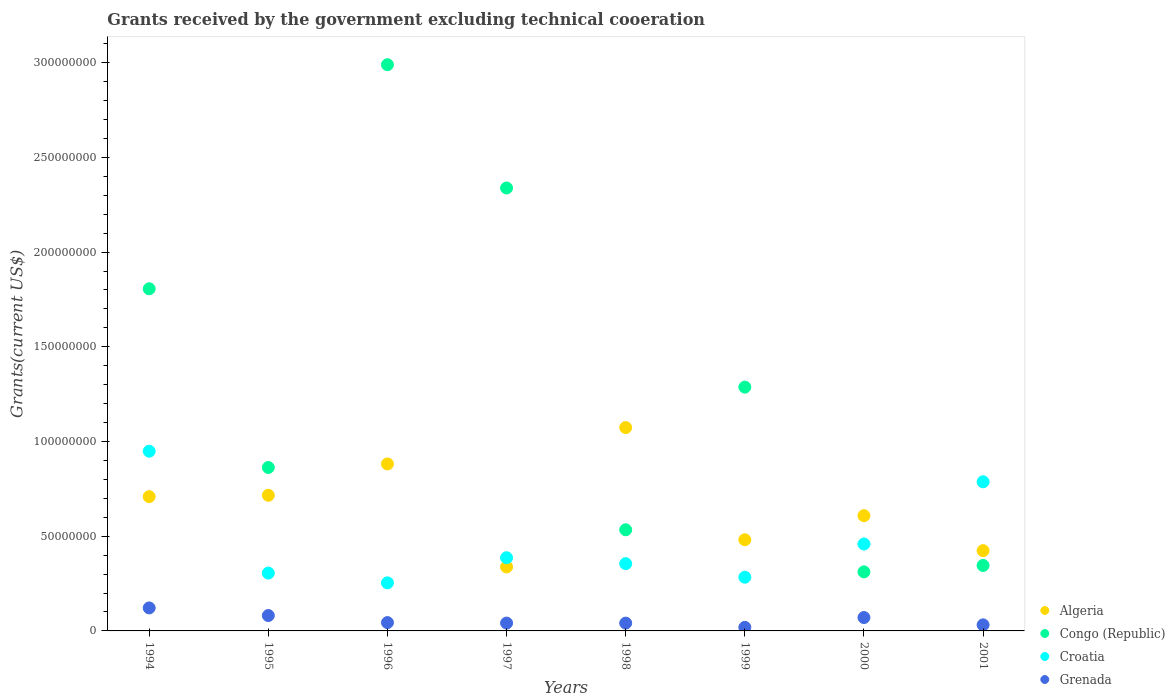Is the number of dotlines equal to the number of legend labels?
Offer a terse response. Yes. What is the total grants received by the government in Croatia in 1999?
Offer a very short reply. 2.84e+07. Across all years, what is the maximum total grants received by the government in Croatia?
Offer a terse response. 9.49e+07. Across all years, what is the minimum total grants received by the government in Grenada?
Provide a succinct answer. 1.88e+06. In which year was the total grants received by the government in Grenada maximum?
Ensure brevity in your answer.  1994. What is the total total grants received by the government in Algeria in the graph?
Provide a succinct answer. 5.23e+08. What is the difference between the total grants received by the government in Algeria in 1995 and that in 1998?
Your answer should be compact. -3.58e+07. What is the difference between the total grants received by the government in Algeria in 1995 and the total grants received by the government in Grenada in 2000?
Keep it short and to the point. 6.45e+07. What is the average total grants received by the government in Grenada per year?
Offer a very short reply. 5.63e+06. In the year 2001, what is the difference between the total grants received by the government in Algeria and total grants received by the government in Grenada?
Provide a succinct answer. 3.92e+07. What is the ratio of the total grants received by the government in Congo (Republic) in 1997 to that in 1999?
Your response must be concise. 1.82. Is the total grants received by the government in Congo (Republic) in 1995 less than that in 1999?
Ensure brevity in your answer.  Yes. Is the difference between the total grants received by the government in Algeria in 1996 and 2000 greater than the difference between the total grants received by the government in Grenada in 1996 and 2000?
Your answer should be very brief. Yes. What is the difference between the highest and the second highest total grants received by the government in Algeria?
Keep it short and to the point. 1.92e+07. What is the difference between the highest and the lowest total grants received by the government in Croatia?
Your answer should be compact. 6.95e+07. Is it the case that in every year, the sum of the total grants received by the government in Croatia and total grants received by the government in Congo (Republic)  is greater than the total grants received by the government in Algeria?
Your response must be concise. No. Is the total grants received by the government in Grenada strictly greater than the total grants received by the government in Croatia over the years?
Your answer should be compact. No. Is the total grants received by the government in Croatia strictly less than the total grants received by the government in Algeria over the years?
Give a very brief answer. No. How many dotlines are there?
Make the answer very short. 4. What is the title of the graph?
Provide a short and direct response. Grants received by the government excluding technical cooeration. Does "Jordan" appear as one of the legend labels in the graph?
Offer a terse response. No. What is the label or title of the Y-axis?
Give a very brief answer. Grants(current US$). What is the Grants(current US$) in Algeria in 1994?
Your response must be concise. 7.09e+07. What is the Grants(current US$) of Congo (Republic) in 1994?
Your answer should be compact. 1.81e+08. What is the Grants(current US$) of Croatia in 1994?
Provide a short and direct response. 9.49e+07. What is the Grants(current US$) in Grenada in 1994?
Keep it short and to the point. 1.21e+07. What is the Grants(current US$) in Algeria in 1995?
Offer a terse response. 7.16e+07. What is the Grants(current US$) in Congo (Republic) in 1995?
Keep it short and to the point. 8.63e+07. What is the Grants(current US$) of Croatia in 1995?
Your answer should be very brief. 3.05e+07. What is the Grants(current US$) of Grenada in 1995?
Provide a short and direct response. 8.12e+06. What is the Grants(current US$) in Algeria in 1996?
Your answer should be compact. 8.82e+07. What is the Grants(current US$) in Congo (Republic) in 1996?
Provide a short and direct response. 2.99e+08. What is the Grants(current US$) of Croatia in 1996?
Offer a very short reply. 2.54e+07. What is the Grants(current US$) of Grenada in 1996?
Provide a short and direct response. 4.40e+06. What is the Grants(current US$) of Algeria in 1997?
Make the answer very short. 3.38e+07. What is the Grants(current US$) in Congo (Republic) in 1997?
Keep it short and to the point. 2.34e+08. What is the Grants(current US$) of Croatia in 1997?
Provide a succinct answer. 3.86e+07. What is the Grants(current US$) of Grenada in 1997?
Give a very brief answer. 4.14e+06. What is the Grants(current US$) of Algeria in 1998?
Your response must be concise. 1.07e+08. What is the Grants(current US$) of Congo (Republic) in 1998?
Provide a short and direct response. 5.34e+07. What is the Grants(current US$) of Croatia in 1998?
Make the answer very short. 3.55e+07. What is the Grants(current US$) in Grenada in 1998?
Provide a short and direct response. 4.12e+06. What is the Grants(current US$) of Algeria in 1999?
Give a very brief answer. 4.81e+07. What is the Grants(current US$) in Congo (Republic) in 1999?
Make the answer very short. 1.29e+08. What is the Grants(current US$) of Croatia in 1999?
Make the answer very short. 2.84e+07. What is the Grants(current US$) of Grenada in 1999?
Ensure brevity in your answer.  1.88e+06. What is the Grants(current US$) of Algeria in 2000?
Make the answer very short. 6.08e+07. What is the Grants(current US$) of Congo (Republic) in 2000?
Your answer should be compact. 3.12e+07. What is the Grants(current US$) in Croatia in 2000?
Ensure brevity in your answer.  4.59e+07. What is the Grants(current US$) of Grenada in 2000?
Give a very brief answer. 7.07e+06. What is the Grants(current US$) of Algeria in 2001?
Your answer should be very brief. 4.24e+07. What is the Grants(current US$) of Congo (Republic) in 2001?
Provide a succinct answer. 3.46e+07. What is the Grants(current US$) of Croatia in 2001?
Your answer should be compact. 7.87e+07. What is the Grants(current US$) in Grenada in 2001?
Offer a terse response. 3.20e+06. Across all years, what is the maximum Grants(current US$) of Algeria?
Make the answer very short. 1.07e+08. Across all years, what is the maximum Grants(current US$) of Congo (Republic)?
Your answer should be very brief. 2.99e+08. Across all years, what is the maximum Grants(current US$) of Croatia?
Provide a short and direct response. 9.49e+07. Across all years, what is the maximum Grants(current US$) in Grenada?
Your response must be concise. 1.21e+07. Across all years, what is the minimum Grants(current US$) in Algeria?
Your response must be concise. 3.38e+07. Across all years, what is the minimum Grants(current US$) of Congo (Republic)?
Make the answer very short. 3.12e+07. Across all years, what is the minimum Grants(current US$) of Croatia?
Keep it short and to the point. 2.54e+07. Across all years, what is the minimum Grants(current US$) in Grenada?
Your response must be concise. 1.88e+06. What is the total Grants(current US$) in Algeria in the graph?
Give a very brief answer. 5.23e+08. What is the total Grants(current US$) of Congo (Republic) in the graph?
Offer a very short reply. 1.05e+09. What is the total Grants(current US$) of Croatia in the graph?
Your response must be concise. 3.78e+08. What is the total Grants(current US$) in Grenada in the graph?
Your answer should be compact. 4.51e+07. What is the difference between the Grants(current US$) in Algeria in 1994 and that in 1995?
Your answer should be compact. -7.10e+05. What is the difference between the Grants(current US$) of Congo (Republic) in 1994 and that in 1995?
Offer a very short reply. 9.43e+07. What is the difference between the Grants(current US$) in Croatia in 1994 and that in 1995?
Provide a short and direct response. 6.43e+07. What is the difference between the Grants(current US$) of Grenada in 1994 and that in 1995?
Provide a succinct answer. 4.02e+06. What is the difference between the Grants(current US$) in Algeria in 1994 and that in 1996?
Offer a terse response. -1.73e+07. What is the difference between the Grants(current US$) of Congo (Republic) in 1994 and that in 1996?
Offer a very short reply. -1.18e+08. What is the difference between the Grants(current US$) of Croatia in 1994 and that in 1996?
Provide a short and direct response. 6.95e+07. What is the difference between the Grants(current US$) of Grenada in 1994 and that in 1996?
Make the answer very short. 7.74e+06. What is the difference between the Grants(current US$) of Algeria in 1994 and that in 1997?
Provide a short and direct response. 3.71e+07. What is the difference between the Grants(current US$) in Congo (Republic) in 1994 and that in 1997?
Offer a terse response. -5.32e+07. What is the difference between the Grants(current US$) in Croatia in 1994 and that in 1997?
Your response must be concise. 5.62e+07. What is the difference between the Grants(current US$) in Algeria in 1994 and that in 1998?
Your response must be concise. -3.65e+07. What is the difference between the Grants(current US$) in Congo (Republic) in 1994 and that in 1998?
Your answer should be compact. 1.27e+08. What is the difference between the Grants(current US$) of Croatia in 1994 and that in 1998?
Your answer should be compact. 5.94e+07. What is the difference between the Grants(current US$) in Grenada in 1994 and that in 1998?
Keep it short and to the point. 8.02e+06. What is the difference between the Grants(current US$) of Algeria in 1994 and that in 1999?
Provide a succinct answer. 2.28e+07. What is the difference between the Grants(current US$) in Congo (Republic) in 1994 and that in 1999?
Give a very brief answer. 5.19e+07. What is the difference between the Grants(current US$) of Croatia in 1994 and that in 1999?
Your answer should be very brief. 6.65e+07. What is the difference between the Grants(current US$) in Grenada in 1994 and that in 1999?
Ensure brevity in your answer.  1.03e+07. What is the difference between the Grants(current US$) in Algeria in 1994 and that in 2000?
Your answer should be very brief. 1.01e+07. What is the difference between the Grants(current US$) in Congo (Republic) in 1994 and that in 2000?
Your response must be concise. 1.49e+08. What is the difference between the Grants(current US$) of Croatia in 1994 and that in 2000?
Offer a terse response. 4.90e+07. What is the difference between the Grants(current US$) in Grenada in 1994 and that in 2000?
Give a very brief answer. 5.07e+06. What is the difference between the Grants(current US$) in Algeria in 1994 and that in 2001?
Make the answer very short. 2.85e+07. What is the difference between the Grants(current US$) of Congo (Republic) in 1994 and that in 2001?
Your answer should be very brief. 1.46e+08. What is the difference between the Grants(current US$) of Croatia in 1994 and that in 2001?
Provide a short and direct response. 1.61e+07. What is the difference between the Grants(current US$) of Grenada in 1994 and that in 2001?
Offer a terse response. 8.94e+06. What is the difference between the Grants(current US$) in Algeria in 1995 and that in 1996?
Your answer should be very brief. -1.66e+07. What is the difference between the Grants(current US$) in Congo (Republic) in 1995 and that in 1996?
Make the answer very short. -2.13e+08. What is the difference between the Grants(current US$) in Croatia in 1995 and that in 1996?
Offer a terse response. 5.17e+06. What is the difference between the Grants(current US$) of Grenada in 1995 and that in 1996?
Give a very brief answer. 3.72e+06. What is the difference between the Grants(current US$) in Algeria in 1995 and that in 1997?
Offer a very short reply. 3.78e+07. What is the difference between the Grants(current US$) in Congo (Republic) in 1995 and that in 1997?
Provide a short and direct response. -1.48e+08. What is the difference between the Grants(current US$) in Croatia in 1995 and that in 1997?
Your answer should be very brief. -8.10e+06. What is the difference between the Grants(current US$) of Grenada in 1995 and that in 1997?
Give a very brief answer. 3.98e+06. What is the difference between the Grants(current US$) of Algeria in 1995 and that in 1998?
Offer a very short reply. -3.58e+07. What is the difference between the Grants(current US$) of Congo (Republic) in 1995 and that in 1998?
Provide a succinct answer. 3.29e+07. What is the difference between the Grants(current US$) of Croatia in 1995 and that in 1998?
Keep it short and to the point. -4.97e+06. What is the difference between the Grants(current US$) in Grenada in 1995 and that in 1998?
Ensure brevity in your answer.  4.00e+06. What is the difference between the Grants(current US$) in Algeria in 1995 and that in 1999?
Keep it short and to the point. 2.35e+07. What is the difference between the Grants(current US$) in Congo (Republic) in 1995 and that in 1999?
Make the answer very short. -4.24e+07. What is the difference between the Grants(current US$) of Croatia in 1995 and that in 1999?
Offer a terse response. 2.19e+06. What is the difference between the Grants(current US$) of Grenada in 1995 and that in 1999?
Provide a succinct answer. 6.24e+06. What is the difference between the Grants(current US$) in Algeria in 1995 and that in 2000?
Your answer should be compact. 1.08e+07. What is the difference between the Grants(current US$) of Congo (Republic) in 1995 and that in 2000?
Offer a very short reply. 5.51e+07. What is the difference between the Grants(current US$) of Croatia in 1995 and that in 2000?
Offer a terse response. -1.53e+07. What is the difference between the Grants(current US$) in Grenada in 1995 and that in 2000?
Offer a terse response. 1.05e+06. What is the difference between the Grants(current US$) of Algeria in 1995 and that in 2001?
Offer a terse response. 2.92e+07. What is the difference between the Grants(current US$) of Congo (Republic) in 1995 and that in 2001?
Make the answer very short. 5.17e+07. What is the difference between the Grants(current US$) of Croatia in 1995 and that in 2001?
Provide a succinct answer. -4.82e+07. What is the difference between the Grants(current US$) in Grenada in 1995 and that in 2001?
Offer a terse response. 4.92e+06. What is the difference between the Grants(current US$) in Algeria in 1996 and that in 1997?
Offer a terse response. 5.44e+07. What is the difference between the Grants(current US$) in Congo (Republic) in 1996 and that in 1997?
Provide a short and direct response. 6.51e+07. What is the difference between the Grants(current US$) in Croatia in 1996 and that in 1997?
Provide a succinct answer. -1.33e+07. What is the difference between the Grants(current US$) in Grenada in 1996 and that in 1997?
Keep it short and to the point. 2.60e+05. What is the difference between the Grants(current US$) in Algeria in 1996 and that in 1998?
Provide a succinct answer. -1.92e+07. What is the difference between the Grants(current US$) in Congo (Republic) in 1996 and that in 1998?
Keep it short and to the point. 2.46e+08. What is the difference between the Grants(current US$) in Croatia in 1996 and that in 1998?
Ensure brevity in your answer.  -1.01e+07. What is the difference between the Grants(current US$) of Algeria in 1996 and that in 1999?
Provide a succinct answer. 4.00e+07. What is the difference between the Grants(current US$) in Congo (Republic) in 1996 and that in 1999?
Your answer should be very brief. 1.70e+08. What is the difference between the Grants(current US$) in Croatia in 1996 and that in 1999?
Offer a very short reply. -2.98e+06. What is the difference between the Grants(current US$) of Grenada in 1996 and that in 1999?
Give a very brief answer. 2.52e+06. What is the difference between the Grants(current US$) in Algeria in 1996 and that in 2000?
Your answer should be compact. 2.73e+07. What is the difference between the Grants(current US$) in Congo (Republic) in 1996 and that in 2000?
Provide a short and direct response. 2.68e+08. What is the difference between the Grants(current US$) of Croatia in 1996 and that in 2000?
Your answer should be very brief. -2.05e+07. What is the difference between the Grants(current US$) in Grenada in 1996 and that in 2000?
Make the answer very short. -2.67e+06. What is the difference between the Grants(current US$) in Algeria in 1996 and that in 2001?
Offer a very short reply. 4.58e+07. What is the difference between the Grants(current US$) in Congo (Republic) in 1996 and that in 2001?
Provide a short and direct response. 2.64e+08. What is the difference between the Grants(current US$) of Croatia in 1996 and that in 2001?
Provide a short and direct response. -5.34e+07. What is the difference between the Grants(current US$) in Grenada in 1996 and that in 2001?
Provide a short and direct response. 1.20e+06. What is the difference between the Grants(current US$) of Algeria in 1997 and that in 1998?
Give a very brief answer. -7.36e+07. What is the difference between the Grants(current US$) of Congo (Republic) in 1997 and that in 1998?
Offer a very short reply. 1.80e+08. What is the difference between the Grants(current US$) in Croatia in 1997 and that in 1998?
Your answer should be compact. 3.13e+06. What is the difference between the Grants(current US$) of Grenada in 1997 and that in 1998?
Your answer should be compact. 2.00e+04. What is the difference between the Grants(current US$) in Algeria in 1997 and that in 1999?
Offer a very short reply. -1.44e+07. What is the difference between the Grants(current US$) in Congo (Republic) in 1997 and that in 1999?
Your response must be concise. 1.05e+08. What is the difference between the Grants(current US$) of Croatia in 1997 and that in 1999?
Your response must be concise. 1.03e+07. What is the difference between the Grants(current US$) of Grenada in 1997 and that in 1999?
Your response must be concise. 2.26e+06. What is the difference between the Grants(current US$) of Algeria in 1997 and that in 2000?
Make the answer very short. -2.71e+07. What is the difference between the Grants(current US$) of Congo (Republic) in 1997 and that in 2000?
Your response must be concise. 2.03e+08. What is the difference between the Grants(current US$) in Croatia in 1997 and that in 2000?
Give a very brief answer. -7.24e+06. What is the difference between the Grants(current US$) of Grenada in 1997 and that in 2000?
Ensure brevity in your answer.  -2.93e+06. What is the difference between the Grants(current US$) in Algeria in 1997 and that in 2001?
Offer a terse response. -8.60e+06. What is the difference between the Grants(current US$) in Congo (Republic) in 1997 and that in 2001?
Keep it short and to the point. 1.99e+08. What is the difference between the Grants(current US$) of Croatia in 1997 and that in 2001?
Keep it short and to the point. -4.01e+07. What is the difference between the Grants(current US$) of Grenada in 1997 and that in 2001?
Your answer should be very brief. 9.40e+05. What is the difference between the Grants(current US$) in Algeria in 1998 and that in 1999?
Your answer should be very brief. 5.92e+07. What is the difference between the Grants(current US$) in Congo (Republic) in 1998 and that in 1999?
Your response must be concise. -7.53e+07. What is the difference between the Grants(current US$) in Croatia in 1998 and that in 1999?
Your answer should be very brief. 7.16e+06. What is the difference between the Grants(current US$) in Grenada in 1998 and that in 1999?
Your response must be concise. 2.24e+06. What is the difference between the Grants(current US$) in Algeria in 1998 and that in 2000?
Make the answer very short. 4.65e+07. What is the difference between the Grants(current US$) of Congo (Republic) in 1998 and that in 2000?
Make the answer very short. 2.22e+07. What is the difference between the Grants(current US$) in Croatia in 1998 and that in 2000?
Ensure brevity in your answer.  -1.04e+07. What is the difference between the Grants(current US$) of Grenada in 1998 and that in 2000?
Give a very brief answer. -2.95e+06. What is the difference between the Grants(current US$) in Algeria in 1998 and that in 2001?
Offer a very short reply. 6.50e+07. What is the difference between the Grants(current US$) of Congo (Republic) in 1998 and that in 2001?
Your answer should be very brief. 1.88e+07. What is the difference between the Grants(current US$) of Croatia in 1998 and that in 2001?
Make the answer very short. -4.32e+07. What is the difference between the Grants(current US$) in Grenada in 1998 and that in 2001?
Your answer should be compact. 9.20e+05. What is the difference between the Grants(current US$) in Algeria in 1999 and that in 2000?
Offer a terse response. -1.27e+07. What is the difference between the Grants(current US$) of Congo (Republic) in 1999 and that in 2000?
Ensure brevity in your answer.  9.75e+07. What is the difference between the Grants(current US$) of Croatia in 1999 and that in 2000?
Keep it short and to the point. -1.75e+07. What is the difference between the Grants(current US$) in Grenada in 1999 and that in 2000?
Make the answer very short. -5.19e+06. What is the difference between the Grants(current US$) in Algeria in 1999 and that in 2001?
Offer a very short reply. 5.76e+06. What is the difference between the Grants(current US$) of Congo (Republic) in 1999 and that in 2001?
Your answer should be compact. 9.41e+07. What is the difference between the Grants(current US$) of Croatia in 1999 and that in 2001?
Offer a very short reply. -5.04e+07. What is the difference between the Grants(current US$) in Grenada in 1999 and that in 2001?
Provide a short and direct response. -1.32e+06. What is the difference between the Grants(current US$) in Algeria in 2000 and that in 2001?
Your response must be concise. 1.85e+07. What is the difference between the Grants(current US$) in Congo (Republic) in 2000 and that in 2001?
Your answer should be very brief. -3.39e+06. What is the difference between the Grants(current US$) of Croatia in 2000 and that in 2001?
Keep it short and to the point. -3.28e+07. What is the difference between the Grants(current US$) in Grenada in 2000 and that in 2001?
Your response must be concise. 3.87e+06. What is the difference between the Grants(current US$) of Algeria in 1994 and the Grants(current US$) of Congo (Republic) in 1995?
Offer a very short reply. -1.54e+07. What is the difference between the Grants(current US$) of Algeria in 1994 and the Grants(current US$) of Croatia in 1995?
Make the answer very short. 4.04e+07. What is the difference between the Grants(current US$) in Algeria in 1994 and the Grants(current US$) in Grenada in 1995?
Provide a short and direct response. 6.28e+07. What is the difference between the Grants(current US$) in Congo (Republic) in 1994 and the Grants(current US$) in Croatia in 1995?
Make the answer very short. 1.50e+08. What is the difference between the Grants(current US$) in Congo (Republic) in 1994 and the Grants(current US$) in Grenada in 1995?
Make the answer very short. 1.73e+08. What is the difference between the Grants(current US$) of Croatia in 1994 and the Grants(current US$) of Grenada in 1995?
Ensure brevity in your answer.  8.67e+07. What is the difference between the Grants(current US$) of Algeria in 1994 and the Grants(current US$) of Congo (Republic) in 1996?
Provide a short and direct response. -2.28e+08. What is the difference between the Grants(current US$) of Algeria in 1994 and the Grants(current US$) of Croatia in 1996?
Give a very brief answer. 4.55e+07. What is the difference between the Grants(current US$) of Algeria in 1994 and the Grants(current US$) of Grenada in 1996?
Make the answer very short. 6.65e+07. What is the difference between the Grants(current US$) of Congo (Republic) in 1994 and the Grants(current US$) of Croatia in 1996?
Your response must be concise. 1.55e+08. What is the difference between the Grants(current US$) of Congo (Republic) in 1994 and the Grants(current US$) of Grenada in 1996?
Provide a short and direct response. 1.76e+08. What is the difference between the Grants(current US$) of Croatia in 1994 and the Grants(current US$) of Grenada in 1996?
Your response must be concise. 9.05e+07. What is the difference between the Grants(current US$) of Algeria in 1994 and the Grants(current US$) of Congo (Republic) in 1997?
Give a very brief answer. -1.63e+08. What is the difference between the Grants(current US$) of Algeria in 1994 and the Grants(current US$) of Croatia in 1997?
Your answer should be compact. 3.23e+07. What is the difference between the Grants(current US$) in Algeria in 1994 and the Grants(current US$) in Grenada in 1997?
Your answer should be compact. 6.68e+07. What is the difference between the Grants(current US$) in Congo (Republic) in 1994 and the Grants(current US$) in Croatia in 1997?
Keep it short and to the point. 1.42e+08. What is the difference between the Grants(current US$) of Congo (Republic) in 1994 and the Grants(current US$) of Grenada in 1997?
Offer a terse response. 1.76e+08. What is the difference between the Grants(current US$) of Croatia in 1994 and the Grants(current US$) of Grenada in 1997?
Make the answer very short. 9.07e+07. What is the difference between the Grants(current US$) of Algeria in 1994 and the Grants(current US$) of Congo (Republic) in 1998?
Your answer should be very brief. 1.75e+07. What is the difference between the Grants(current US$) in Algeria in 1994 and the Grants(current US$) in Croatia in 1998?
Your answer should be compact. 3.54e+07. What is the difference between the Grants(current US$) of Algeria in 1994 and the Grants(current US$) of Grenada in 1998?
Offer a terse response. 6.68e+07. What is the difference between the Grants(current US$) of Congo (Republic) in 1994 and the Grants(current US$) of Croatia in 1998?
Provide a succinct answer. 1.45e+08. What is the difference between the Grants(current US$) of Congo (Republic) in 1994 and the Grants(current US$) of Grenada in 1998?
Provide a succinct answer. 1.77e+08. What is the difference between the Grants(current US$) of Croatia in 1994 and the Grants(current US$) of Grenada in 1998?
Offer a very short reply. 9.07e+07. What is the difference between the Grants(current US$) in Algeria in 1994 and the Grants(current US$) in Congo (Republic) in 1999?
Your response must be concise. -5.78e+07. What is the difference between the Grants(current US$) in Algeria in 1994 and the Grants(current US$) in Croatia in 1999?
Your answer should be compact. 4.26e+07. What is the difference between the Grants(current US$) of Algeria in 1994 and the Grants(current US$) of Grenada in 1999?
Offer a terse response. 6.90e+07. What is the difference between the Grants(current US$) of Congo (Republic) in 1994 and the Grants(current US$) of Croatia in 1999?
Your answer should be compact. 1.52e+08. What is the difference between the Grants(current US$) in Congo (Republic) in 1994 and the Grants(current US$) in Grenada in 1999?
Keep it short and to the point. 1.79e+08. What is the difference between the Grants(current US$) in Croatia in 1994 and the Grants(current US$) in Grenada in 1999?
Offer a very short reply. 9.30e+07. What is the difference between the Grants(current US$) in Algeria in 1994 and the Grants(current US$) in Congo (Republic) in 2000?
Provide a short and direct response. 3.97e+07. What is the difference between the Grants(current US$) in Algeria in 1994 and the Grants(current US$) in Croatia in 2000?
Your answer should be very brief. 2.50e+07. What is the difference between the Grants(current US$) of Algeria in 1994 and the Grants(current US$) of Grenada in 2000?
Give a very brief answer. 6.38e+07. What is the difference between the Grants(current US$) in Congo (Republic) in 1994 and the Grants(current US$) in Croatia in 2000?
Your response must be concise. 1.35e+08. What is the difference between the Grants(current US$) of Congo (Republic) in 1994 and the Grants(current US$) of Grenada in 2000?
Provide a succinct answer. 1.74e+08. What is the difference between the Grants(current US$) in Croatia in 1994 and the Grants(current US$) in Grenada in 2000?
Give a very brief answer. 8.78e+07. What is the difference between the Grants(current US$) of Algeria in 1994 and the Grants(current US$) of Congo (Republic) in 2001?
Offer a very short reply. 3.63e+07. What is the difference between the Grants(current US$) in Algeria in 1994 and the Grants(current US$) in Croatia in 2001?
Offer a terse response. -7.83e+06. What is the difference between the Grants(current US$) of Algeria in 1994 and the Grants(current US$) of Grenada in 2001?
Your answer should be compact. 6.77e+07. What is the difference between the Grants(current US$) of Congo (Republic) in 1994 and the Grants(current US$) of Croatia in 2001?
Make the answer very short. 1.02e+08. What is the difference between the Grants(current US$) in Congo (Republic) in 1994 and the Grants(current US$) in Grenada in 2001?
Keep it short and to the point. 1.77e+08. What is the difference between the Grants(current US$) in Croatia in 1994 and the Grants(current US$) in Grenada in 2001?
Offer a very short reply. 9.17e+07. What is the difference between the Grants(current US$) in Algeria in 1995 and the Grants(current US$) in Congo (Republic) in 1996?
Offer a very short reply. -2.27e+08. What is the difference between the Grants(current US$) of Algeria in 1995 and the Grants(current US$) of Croatia in 1996?
Offer a terse response. 4.62e+07. What is the difference between the Grants(current US$) of Algeria in 1995 and the Grants(current US$) of Grenada in 1996?
Your answer should be compact. 6.72e+07. What is the difference between the Grants(current US$) of Congo (Republic) in 1995 and the Grants(current US$) of Croatia in 1996?
Your response must be concise. 6.09e+07. What is the difference between the Grants(current US$) of Congo (Republic) in 1995 and the Grants(current US$) of Grenada in 1996?
Keep it short and to the point. 8.19e+07. What is the difference between the Grants(current US$) of Croatia in 1995 and the Grants(current US$) of Grenada in 1996?
Offer a terse response. 2.61e+07. What is the difference between the Grants(current US$) of Algeria in 1995 and the Grants(current US$) of Congo (Republic) in 1997?
Provide a short and direct response. -1.62e+08. What is the difference between the Grants(current US$) in Algeria in 1995 and the Grants(current US$) in Croatia in 1997?
Offer a terse response. 3.30e+07. What is the difference between the Grants(current US$) of Algeria in 1995 and the Grants(current US$) of Grenada in 1997?
Provide a short and direct response. 6.75e+07. What is the difference between the Grants(current US$) of Congo (Republic) in 1995 and the Grants(current US$) of Croatia in 1997?
Your answer should be compact. 4.76e+07. What is the difference between the Grants(current US$) in Congo (Republic) in 1995 and the Grants(current US$) in Grenada in 1997?
Offer a terse response. 8.22e+07. What is the difference between the Grants(current US$) in Croatia in 1995 and the Grants(current US$) in Grenada in 1997?
Offer a terse response. 2.64e+07. What is the difference between the Grants(current US$) of Algeria in 1995 and the Grants(current US$) of Congo (Republic) in 1998?
Offer a very short reply. 1.82e+07. What is the difference between the Grants(current US$) of Algeria in 1995 and the Grants(current US$) of Croatia in 1998?
Keep it short and to the point. 3.61e+07. What is the difference between the Grants(current US$) of Algeria in 1995 and the Grants(current US$) of Grenada in 1998?
Provide a short and direct response. 6.75e+07. What is the difference between the Grants(current US$) in Congo (Republic) in 1995 and the Grants(current US$) in Croatia in 1998?
Offer a very short reply. 5.08e+07. What is the difference between the Grants(current US$) in Congo (Republic) in 1995 and the Grants(current US$) in Grenada in 1998?
Provide a succinct answer. 8.22e+07. What is the difference between the Grants(current US$) in Croatia in 1995 and the Grants(current US$) in Grenada in 1998?
Offer a very short reply. 2.64e+07. What is the difference between the Grants(current US$) in Algeria in 1995 and the Grants(current US$) in Congo (Republic) in 1999?
Ensure brevity in your answer.  -5.71e+07. What is the difference between the Grants(current US$) in Algeria in 1995 and the Grants(current US$) in Croatia in 1999?
Keep it short and to the point. 4.33e+07. What is the difference between the Grants(current US$) of Algeria in 1995 and the Grants(current US$) of Grenada in 1999?
Your response must be concise. 6.97e+07. What is the difference between the Grants(current US$) in Congo (Republic) in 1995 and the Grants(current US$) in Croatia in 1999?
Ensure brevity in your answer.  5.79e+07. What is the difference between the Grants(current US$) in Congo (Republic) in 1995 and the Grants(current US$) in Grenada in 1999?
Your answer should be very brief. 8.44e+07. What is the difference between the Grants(current US$) of Croatia in 1995 and the Grants(current US$) of Grenada in 1999?
Provide a short and direct response. 2.87e+07. What is the difference between the Grants(current US$) of Algeria in 1995 and the Grants(current US$) of Congo (Republic) in 2000?
Provide a succinct answer. 4.04e+07. What is the difference between the Grants(current US$) of Algeria in 1995 and the Grants(current US$) of Croatia in 2000?
Your answer should be compact. 2.57e+07. What is the difference between the Grants(current US$) in Algeria in 1995 and the Grants(current US$) in Grenada in 2000?
Provide a succinct answer. 6.45e+07. What is the difference between the Grants(current US$) of Congo (Republic) in 1995 and the Grants(current US$) of Croatia in 2000?
Ensure brevity in your answer.  4.04e+07. What is the difference between the Grants(current US$) in Congo (Republic) in 1995 and the Grants(current US$) in Grenada in 2000?
Your answer should be compact. 7.92e+07. What is the difference between the Grants(current US$) of Croatia in 1995 and the Grants(current US$) of Grenada in 2000?
Keep it short and to the point. 2.35e+07. What is the difference between the Grants(current US$) in Algeria in 1995 and the Grants(current US$) in Congo (Republic) in 2001?
Offer a very short reply. 3.70e+07. What is the difference between the Grants(current US$) in Algeria in 1995 and the Grants(current US$) in Croatia in 2001?
Your answer should be very brief. -7.12e+06. What is the difference between the Grants(current US$) of Algeria in 1995 and the Grants(current US$) of Grenada in 2001?
Your answer should be compact. 6.84e+07. What is the difference between the Grants(current US$) in Congo (Republic) in 1995 and the Grants(current US$) in Croatia in 2001?
Offer a very short reply. 7.56e+06. What is the difference between the Grants(current US$) in Congo (Republic) in 1995 and the Grants(current US$) in Grenada in 2001?
Provide a succinct answer. 8.31e+07. What is the difference between the Grants(current US$) in Croatia in 1995 and the Grants(current US$) in Grenada in 2001?
Your answer should be compact. 2.73e+07. What is the difference between the Grants(current US$) in Algeria in 1996 and the Grants(current US$) in Congo (Republic) in 1997?
Offer a terse response. -1.46e+08. What is the difference between the Grants(current US$) of Algeria in 1996 and the Grants(current US$) of Croatia in 1997?
Your response must be concise. 4.95e+07. What is the difference between the Grants(current US$) in Algeria in 1996 and the Grants(current US$) in Grenada in 1997?
Your answer should be compact. 8.40e+07. What is the difference between the Grants(current US$) of Congo (Republic) in 1996 and the Grants(current US$) of Croatia in 1997?
Provide a short and direct response. 2.60e+08. What is the difference between the Grants(current US$) of Congo (Republic) in 1996 and the Grants(current US$) of Grenada in 1997?
Provide a succinct answer. 2.95e+08. What is the difference between the Grants(current US$) of Croatia in 1996 and the Grants(current US$) of Grenada in 1997?
Keep it short and to the point. 2.12e+07. What is the difference between the Grants(current US$) of Algeria in 1996 and the Grants(current US$) of Congo (Republic) in 1998?
Your answer should be compact. 3.48e+07. What is the difference between the Grants(current US$) in Algeria in 1996 and the Grants(current US$) in Croatia in 1998?
Offer a terse response. 5.26e+07. What is the difference between the Grants(current US$) in Algeria in 1996 and the Grants(current US$) in Grenada in 1998?
Give a very brief answer. 8.40e+07. What is the difference between the Grants(current US$) of Congo (Republic) in 1996 and the Grants(current US$) of Croatia in 1998?
Make the answer very short. 2.63e+08. What is the difference between the Grants(current US$) of Congo (Republic) in 1996 and the Grants(current US$) of Grenada in 1998?
Make the answer very short. 2.95e+08. What is the difference between the Grants(current US$) in Croatia in 1996 and the Grants(current US$) in Grenada in 1998?
Offer a very short reply. 2.12e+07. What is the difference between the Grants(current US$) of Algeria in 1996 and the Grants(current US$) of Congo (Republic) in 1999?
Your response must be concise. -4.05e+07. What is the difference between the Grants(current US$) in Algeria in 1996 and the Grants(current US$) in Croatia in 1999?
Offer a very short reply. 5.98e+07. What is the difference between the Grants(current US$) in Algeria in 1996 and the Grants(current US$) in Grenada in 1999?
Provide a succinct answer. 8.63e+07. What is the difference between the Grants(current US$) in Congo (Republic) in 1996 and the Grants(current US$) in Croatia in 1999?
Your answer should be compact. 2.71e+08. What is the difference between the Grants(current US$) of Congo (Republic) in 1996 and the Grants(current US$) of Grenada in 1999?
Keep it short and to the point. 2.97e+08. What is the difference between the Grants(current US$) of Croatia in 1996 and the Grants(current US$) of Grenada in 1999?
Your answer should be very brief. 2.35e+07. What is the difference between the Grants(current US$) in Algeria in 1996 and the Grants(current US$) in Congo (Republic) in 2000?
Give a very brief answer. 5.70e+07. What is the difference between the Grants(current US$) of Algeria in 1996 and the Grants(current US$) of Croatia in 2000?
Offer a very short reply. 4.23e+07. What is the difference between the Grants(current US$) in Algeria in 1996 and the Grants(current US$) in Grenada in 2000?
Provide a short and direct response. 8.11e+07. What is the difference between the Grants(current US$) in Congo (Republic) in 1996 and the Grants(current US$) in Croatia in 2000?
Provide a short and direct response. 2.53e+08. What is the difference between the Grants(current US$) of Congo (Republic) in 1996 and the Grants(current US$) of Grenada in 2000?
Provide a succinct answer. 2.92e+08. What is the difference between the Grants(current US$) in Croatia in 1996 and the Grants(current US$) in Grenada in 2000?
Give a very brief answer. 1.83e+07. What is the difference between the Grants(current US$) of Algeria in 1996 and the Grants(current US$) of Congo (Republic) in 2001?
Provide a succinct answer. 5.36e+07. What is the difference between the Grants(current US$) in Algeria in 1996 and the Grants(current US$) in Croatia in 2001?
Your answer should be very brief. 9.43e+06. What is the difference between the Grants(current US$) in Algeria in 1996 and the Grants(current US$) in Grenada in 2001?
Provide a succinct answer. 8.50e+07. What is the difference between the Grants(current US$) in Congo (Republic) in 1996 and the Grants(current US$) in Croatia in 2001?
Keep it short and to the point. 2.20e+08. What is the difference between the Grants(current US$) in Congo (Republic) in 1996 and the Grants(current US$) in Grenada in 2001?
Provide a short and direct response. 2.96e+08. What is the difference between the Grants(current US$) in Croatia in 1996 and the Grants(current US$) in Grenada in 2001?
Provide a short and direct response. 2.22e+07. What is the difference between the Grants(current US$) of Algeria in 1997 and the Grants(current US$) of Congo (Republic) in 1998?
Give a very brief answer. -1.96e+07. What is the difference between the Grants(current US$) in Algeria in 1997 and the Grants(current US$) in Croatia in 1998?
Keep it short and to the point. -1.73e+06. What is the difference between the Grants(current US$) of Algeria in 1997 and the Grants(current US$) of Grenada in 1998?
Give a very brief answer. 2.97e+07. What is the difference between the Grants(current US$) in Congo (Republic) in 1997 and the Grants(current US$) in Croatia in 1998?
Offer a very short reply. 1.98e+08. What is the difference between the Grants(current US$) in Congo (Republic) in 1997 and the Grants(current US$) in Grenada in 1998?
Keep it short and to the point. 2.30e+08. What is the difference between the Grants(current US$) in Croatia in 1997 and the Grants(current US$) in Grenada in 1998?
Offer a terse response. 3.45e+07. What is the difference between the Grants(current US$) of Algeria in 1997 and the Grants(current US$) of Congo (Republic) in 1999?
Your answer should be very brief. -9.49e+07. What is the difference between the Grants(current US$) of Algeria in 1997 and the Grants(current US$) of Croatia in 1999?
Your answer should be compact. 5.43e+06. What is the difference between the Grants(current US$) of Algeria in 1997 and the Grants(current US$) of Grenada in 1999?
Your answer should be very brief. 3.19e+07. What is the difference between the Grants(current US$) of Congo (Republic) in 1997 and the Grants(current US$) of Croatia in 1999?
Ensure brevity in your answer.  2.05e+08. What is the difference between the Grants(current US$) of Congo (Republic) in 1997 and the Grants(current US$) of Grenada in 1999?
Your answer should be compact. 2.32e+08. What is the difference between the Grants(current US$) in Croatia in 1997 and the Grants(current US$) in Grenada in 1999?
Give a very brief answer. 3.68e+07. What is the difference between the Grants(current US$) of Algeria in 1997 and the Grants(current US$) of Congo (Republic) in 2000?
Your response must be concise. 2.61e+06. What is the difference between the Grants(current US$) in Algeria in 1997 and the Grants(current US$) in Croatia in 2000?
Keep it short and to the point. -1.21e+07. What is the difference between the Grants(current US$) of Algeria in 1997 and the Grants(current US$) of Grenada in 2000?
Ensure brevity in your answer.  2.67e+07. What is the difference between the Grants(current US$) in Congo (Republic) in 1997 and the Grants(current US$) in Croatia in 2000?
Give a very brief answer. 1.88e+08. What is the difference between the Grants(current US$) in Congo (Republic) in 1997 and the Grants(current US$) in Grenada in 2000?
Your answer should be compact. 2.27e+08. What is the difference between the Grants(current US$) of Croatia in 1997 and the Grants(current US$) of Grenada in 2000?
Provide a short and direct response. 3.16e+07. What is the difference between the Grants(current US$) in Algeria in 1997 and the Grants(current US$) in Congo (Republic) in 2001?
Offer a very short reply. -7.80e+05. What is the difference between the Grants(current US$) in Algeria in 1997 and the Grants(current US$) in Croatia in 2001?
Your response must be concise. -4.50e+07. What is the difference between the Grants(current US$) of Algeria in 1997 and the Grants(current US$) of Grenada in 2001?
Provide a succinct answer. 3.06e+07. What is the difference between the Grants(current US$) in Congo (Republic) in 1997 and the Grants(current US$) in Croatia in 2001?
Your response must be concise. 1.55e+08. What is the difference between the Grants(current US$) in Congo (Republic) in 1997 and the Grants(current US$) in Grenada in 2001?
Provide a short and direct response. 2.31e+08. What is the difference between the Grants(current US$) of Croatia in 1997 and the Grants(current US$) of Grenada in 2001?
Offer a terse response. 3.54e+07. What is the difference between the Grants(current US$) in Algeria in 1998 and the Grants(current US$) in Congo (Republic) in 1999?
Give a very brief answer. -2.13e+07. What is the difference between the Grants(current US$) in Algeria in 1998 and the Grants(current US$) in Croatia in 1999?
Your response must be concise. 7.90e+07. What is the difference between the Grants(current US$) in Algeria in 1998 and the Grants(current US$) in Grenada in 1999?
Ensure brevity in your answer.  1.05e+08. What is the difference between the Grants(current US$) in Congo (Republic) in 1998 and the Grants(current US$) in Croatia in 1999?
Provide a succinct answer. 2.50e+07. What is the difference between the Grants(current US$) in Congo (Republic) in 1998 and the Grants(current US$) in Grenada in 1999?
Make the answer very short. 5.15e+07. What is the difference between the Grants(current US$) of Croatia in 1998 and the Grants(current US$) of Grenada in 1999?
Offer a terse response. 3.36e+07. What is the difference between the Grants(current US$) of Algeria in 1998 and the Grants(current US$) of Congo (Republic) in 2000?
Your answer should be compact. 7.62e+07. What is the difference between the Grants(current US$) in Algeria in 1998 and the Grants(current US$) in Croatia in 2000?
Keep it short and to the point. 6.15e+07. What is the difference between the Grants(current US$) in Algeria in 1998 and the Grants(current US$) in Grenada in 2000?
Keep it short and to the point. 1.00e+08. What is the difference between the Grants(current US$) in Congo (Republic) in 1998 and the Grants(current US$) in Croatia in 2000?
Ensure brevity in your answer.  7.51e+06. What is the difference between the Grants(current US$) of Congo (Republic) in 1998 and the Grants(current US$) of Grenada in 2000?
Give a very brief answer. 4.63e+07. What is the difference between the Grants(current US$) of Croatia in 1998 and the Grants(current US$) of Grenada in 2000?
Your answer should be very brief. 2.84e+07. What is the difference between the Grants(current US$) of Algeria in 1998 and the Grants(current US$) of Congo (Republic) in 2001?
Your answer should be very brief. 7.28e+07. What is the difference between the Grants(current US$) in Algeria in 1998 and the Grants(current US$) in Croatia in 2001?
Offer a very short reply. 2.86e+07. What is the difference between the Grants(current US$) in Algeria in 1998 and the Grants(current US$) in Grenada in 2001?
Your answer should be compact. 1.04e+08. What is the difference between the Grants(current US$) of Congo (Republic) in 1998 and the Grants(current US$) of Croatia in 2001?
Give a very brief answer. -2.53e+07. What is the difference between the Grants(current US$) in Congo (Republic) in 1998 and the Grants(current US$) in Grenada in 2001?
Make the answer very short. 5.02e+07. What is the difference between the Grants(current US$) in Croatia in 1998 and the Grants(current US$) in Grenada in 2001?
Ensure brevity in your answer.  3.23e+07. What is the difference between the Grants(current US$) of Algeria in 1999 and the Grants(current US$) of Congo (Republic) in 2000?
Your response must be concise. 1.70e+07. What is the difference between the Grants(current US$) in Algeria in 1999 and the Grants(current US$) in Croatia in 2000?
Keep it short and to the point. 2.26e+06. What is the difference between the Grants(current US$) in Algeria in 1999 and the Grants(current US$) in Grenada in 2000?
Your response must be concise. 4.11e+07. What is the difference between the Grants(current US$) of Congo (Republic) in 1999 and the Grants(current US$) of Croatia in 2000?
Provide a short and direct response. 8.28e+07. What is the difference between the Grants(current US$) in Congo (Republic) in 1999 and the Grants(current US$) in Grenada in 2000?
Give a very brief answer. 1.22e+08. What is the difference between the Grants(current US$) in Croatia in 1999 and the Grants(current US$) in Grenada in 2000?
Keep it short and to the point. 2.13e+07. What is the difference between the Grants(current US$) in Algeria in 1999 and the Grants(current US$) in Congo (Republic) in 2001?
Make the answer very short. 1.36e+07. What is the difference between the Grants(current US$) in Algeria in 1999 and the Grants(current US$) in Croatia in 2001?
Provide a succinct answer. -3.06e+07. What is the difference between the Grants(current US$) of Algeria in 1999 and the Grants(current US$) of Grenada in 2001?
Make the answer very short. 4.49e+07. What is the difference between the Grants(current US$) in Congo (Republic) in 1999 and the Grants(current US$) in Croatia in 2001?
Ensure brevity in your answer.  5.00e+07. What is the difference between the Grants(current US$) in Congo (Republic) in 1999 and the Grants(current US$) in Grenada in 2001?
Offer a terse response. 1.26e+08. What is the difference between the Grants(current US$) of Croatia in 1999 and the Grants(current US$) of Grenada in 2001?
Your answer should be compact. 2.52e+07. What is the difference between the Grants(current US$) in Algeria in 2000 and the Grants(current US$) in Congo (Republic) in 2001?
Keep it short and to the point. 2.63e+07. What is the difference between the Grants(current US$) in Algeria in 2000 and the Grants(current US$) in Croatia in 2001?
Offer a very short reply. -1.79e+07. What is the difference between the Grants(current US$) of Algeria in 2000 and the Grants(current US$) of Grenada in 2001?
Ensure brevity in your answer.  5.76e+07. What is the difference between the Grants(current US$) of Congo (Republic) in 2000 and the Grants(current US$) of Croatia in 2001?
Keep it short and to the point. -4.76e+07. What is the difference between the Grants(current US$) of Congo (Republic) in 2000 and the Grants(current US$) of Grenada in 2001?
Offer a very short reply. 2.80e+07. What is the difference between the Grants(current US$) of Croatia in 2000 and the Grants(current US$) of Grenada in 2001?
Your response must be concise. 4.27e+07. What is the average Grants(current US$) of Algeria per year?
Give a very brief answer. 6.54e+07. What is the average Grants(current US$) in Congo (Republic) per year?
Offer a terse response. 1.31e+08. What is the average Grants(current US$) of Croatia per year?
Ensure brevity in your answer.  4.72e+07. What is the average Grants(current US$) of Grenada per year?
Keep it short and to the point. 5.63e+06. In the year 1994, what is the difference between the Grants(current US$) in Algeria and Grants(current US$) in Congo (Republic)?
Give a very brief answer. -1.10e+08. In the year 1994, what is the difference between the Grants(current US$) of Algeria and Grants(current US$) of Croatia?
Provide a short and direct response. -2.40e+07. In the year 1994, what is the difference between the Grants(current US$) of Algeria and Grants(current US$) of Grenada?
Your answer should be very brief. 5.88e+07. In the year 1994, what is the difference between the Grants(current US$) of Congo (Republic) and Grants(current US$) of Croatia?
Offer a very short reply. 8.58e+07. In the year 1994, what is the difference between the Grants(current US$) in Congo (Republic) and Grants(current US$) in Grenada?
Give a very brief answer. 1.68e+08. In the year 1994, what is the difference between the Grants(current US$) of Croatia and Grants(current US$) of Grenada?
Provide a succinct answer. 8.27e+07. In the year 1995, what is the difference between the Grants(current US$) of Algeria and Grants(current US$) of Congo (Republic)?
Your answer should be very brief. -1.47e+07. In the year 1995, what is the difference between the Grants(current US$) in Algeria and Grants(current US$) in Croatia?
Offer a terse response. 4.11e+07. In the year 1995, what is the difference between the Grants(current US$) in Algeria and Grants(current US$) in Grenada?
Provide a succinct answer. 6.35e+07. In the year 1995, what is the difference between the Grants(current US$) of Congo (Republic) and Grants(current US$) of Croatia?
Your response must be concise. 5.58e+07. In the year 1995, what is the difference between the Grants(current US$) in Congo (Republic) and Grants(current US$) in Grenada?
Your answer should be very brief. 7.82e+07. In the year 1995, what is the difference between the Grants(current US$) of Croatia and Grants(current US$) of Grenada?
Provide a short and direct response. 2.24e+07. In the year 1996, what is the difference between the Grants(current US$) of Algeria and Grants(current US$) of Congo (Republic)?
Offer a very short reply. -2.11e+08. In the year 1996, what is the difference between the Grants(current US$) of Algeria and Grants(current US$) of Croatia?
Make the answer very short. 6.28e+07. In the year 1996, what is the difference between the Grants(current US$) of Algeria and Grants(current US$) of Grenada?
Provide a succinct answer. 8.38e+07. In the year 1996, what is the difference between the Grants(current US$) in Congo (Republic) and Grants(current US$) in Croatia?
Provide a succinct answer. 2.74e+08. In the year 1996, what is the difference between the Grants(current US$) of Congo (Republic) and Grants(current US$) of Grenada?
Give a very brief answer. 2.95e+08. In the year 1996, what is the difference between the Grants(current US$) of Croatia and Grants(current US$) of Grenada?
Give a very brief answer. 2.10e+07. In the year 1997, what is the difference between the Grants(current US$) in Algeria and Grants(current US$) in Congo (Republic)?
Offer a terse response. -2.00e+08. In the year 1997, what is the difference between the Grants(current US$) of Algeria and Grants(current US$) of Croatia?
Ensure brevity in your answer.  -4.86e+06. In the year 1997, what is the difference between the Grants(current US$) of Algeria and Grants(current US$) of Grenada?
Offer a terse response. 2.96e+07. In the year 1997, what is the difference between the Grants(current US$) of Congo (Republic) and Grants(current US$) of Croatia?
Provide a succinct answer. 1.95e+08. In the year 1997, what is the difference between the Grants(current US$) of Congo (Republic) and Grants(current US$) of Grenada?
Your answer should be very brief. 2.30e+08. In the year 1997, what is the difference between the Grants(current US$) in Croatia and Grants(current US$) in Grenada?
Ensure brevity in your answer.  3.45e+07. In the year 1998, what is the difference between the Grants(current US$) of Algeria and Grants(current US$) of Congo (Republic)?
Give a very brief answer. 5.40e+07. In the year 1998, what is the difference between the Grants(current US$) of Algeria and Grants(current US$) of Croatia?
Give a very brief answer. 7.18e+07. In the year 1998, what is the difference between the Grants(current US$) in Algeria and Grants(current US$) in Grenada?
Ensure brevity in your answer.  1.03e+08. In the year 1998, what is the difference between the Grants(current US$) of Congo (Republic) and Grants(current US$) of Croatia?
Provide a short and direct response. 1.79e+07. In the year 1998, what is the difference between the Grants(current US$) in Congo (Republic) and Grants(current US$) in Grenada?
Ensure brevity in your answer.  4.93e+07. In the year 1998, what is the difference between the Grants(current US$) in Croatia and Grants(current US$) in Grenada?
Provide a succinct answer. 3.14e+07. In the year 1999, what is the difference between the Grants(current US$) in Algeria and Grants(current US$) in Congo (Republic)?
Your answer should be compact. -8.06e+07. In the year 1999, what is the difference between the Grants(current US$) in Algeria and Grants(current US$) in Croatia?
Provide a succinct answer. 1.98e+07. In the year 1999, what is the difference between the Grants(current US$) in Algeria and Grants(current US$) in Grenada?
Provide a succinct answer. 4.63e+07. In the year 1999, what is the difference between the Grants(current US$) in Congo (Republic) and Grants(current US$) in Croatia?
Make the answer very short. 1.00e+08. In the year 1999, what is the difference between the Grants(current US$) of Congo (Republic) and Grants(current US$) of Grenada?
Keep it short and to the point. 1.27e+08. In the year 1999, what is the difference between the Grants(current US$) in Croatia and Grants(current US$) in Grenada?
Provide a succinct answer. 2.65e+07. In the year 2000, what is the difference between the Grants(current US$) of Algeria and Grants(current US$) of Congo (Republic)?
Offer a very short reply. 2.97e+07. In the year 2000, what is the difference between the Grants(current US$) of Algeria and Grants(current US$) of Croatia?
Keep it short and to the point. 1.50e+07. In the year 2000, what is the difference between the Grants(current US$) of Algeria and Grants(current US$) of Grenada?
Your answer should be very brief. 5.38e+07. In the year 2000, what is the difference between the Grants(current US$) of Congo (Republic) and Grants(current US$) of Croatia?
Your answer should be compact. -1.47e+07. In the year 2000, what is the difference between the Grants(current US$) of Congo (Republic) and Grants(current US$) of Grenada?
Keep it short and to the point. 2.41e+07. In the year 2000, what is the difference between the Grants(current US$) in Croatia and Grants(current US$) in Grenada?
Make the answer very short. 3.88e+07. In the year 2001, what is the difference between the Grants(current US$) of Algeria and Grants(current US$) of Congo (Republic)?
Keep it short and to the point. 7.82e+06. In the year 2001, what is the difference between the Grants(current US$) of Algeria and Grants(current US$) of Croatia?
Provide a succinct answer. -3.64e+07. In the year 2001, what is the difference between the Grants(current US$) of Algeria and Grants(current US$) of Grenada?
Your response must be concise. 3.92e+07. In the year 2001, what is the difference between the Grants(current US$) in Congo (Republic) and Grants(current US$) in Croatia?
Ensure brevity in your answer.  -4.42e+07. In the year 2001, what is the difference between the Grants(current US$) of Congo (Republic) and Grants(current US$) of Grenada?
Your answer should be very brief. 3.14e+07. In the year 2001, what is the difference between the Grants(current US$) in Croatia and Grants(current US$) in Grenada?
Make the answer very short. 7.55e+07. What is the ratio of the Grants(current US$) of Algeria in 1994 to that in 1995?
Your answer should be compact. 0.99. What is the ratio of the Grants(current US$) of Congo (Republic) in 1994 to that in 1995?
Your answer should be compact. 2.09. What is the ratio of the Grants(current US$) of Croatia in 1994 to that in 1995?
Make the answer very short. 3.11. What is the ratio of the Grants(current US$) of Grenada in 1994 to that in 1995?
Your response must be concise. 1.5. What is the ratio of the Grants(current US$) in Algeria in 1994 to that in 1996?
Ensure brevity in your answer.  0.8. What is the ratio of the Grants(current US$) of Congo (Republic) in 1994 to that in 1996?
Give a very brief answer. 0.6. What is the ratio of the Grants(current US$) of Croatia in 1994 to that in 1996?
Make the answer very short. 3.74. What is the ratio of the Grants(current US$) in Grenada in 1994 to that in 1996?
Your response must be concise. 2.76. What is the ratio of the Grants(current US$) in Algeria in 1994 to that in 1997?
Your answer should be very brief. 2.1. What is the ratio of the Grants(current US$) in Congo (Republic) in 1994 to that in 1997?
Provide a succinct answer. 0.77. What is the ratio of the Grants(current US$) of Croatia in 1994 to that in 1997?
Provide a short and direct response. 2.46. What is the ratio of the Grants(current US$) of Grenada in 1994 to that in 1997?
Keep it short and to the point. 2.93. What is the ratio of the Grants(current US$) in Algeria in 1994 to that in 1998?
Provide a short and direct response. 0.66. What is the ratio of the Grants(current US$) in Congo (Republic) in 1994 to that in 1998?
Provide a short and direct response. 3.38. What is the ratio of the Grants(current US$) of Croatia in 1994 to that in 1998?
Your answer should be very brief. 2.67. What is the ratio of the Grants(current US$) of Grenada in 1994 to that in 1998?
Offer a terse response. 2.95. What is the ratio of the Grants(current US$) in Algeria in 1994 to that in 1999?
Your response must be concise. 1.47. What is the ratio of the Grants(current US$) in Congo (Republic) in 1994 to that in 1999?
Your answer should be very brief. 1.4. What is the ratio of the Grants(current US$) of Croatia in 1994 to that in 1999?
Give a very brief answer. 3.35. What is the ratio of the Grants(current US$) of Grenada in 1994 to that in 1999?
Your answer should be very brief. 6.46. What is the ratio of the Grants(current US$) in Algeria in 1994 to that in 2000?
Provide a succinct answer. 1.17. What is the ratio of the Grants(current US$) in Congo (Republic) in 1994 to that in 2000?
Your answer should be compact. 5.79. What is the ratio of the Grants(current US$) of Croatia in 1994 to that in 2000?
Ensure brevity in your answer.  2.07. What is the ratio of the Grants(current US$) in Grenada in 1994 to that in 2000?
Provide a short and direct response. 1.72. What is the ratio of the Grants(current US$) in Algeria in 1994 to that in 2001?
Provide a succinct answer. 1.67. What is the ratio of the Grants(current US$) of Congo (Republic) in 1994 to that in 2001?
Give a very brief answer. 5.23. What is the ratio of the Grants(current US$) of Croatia in 1994 to that in 2001?
Provide a short and direct response. 1.2. What is the ratio of the Grants(current US$) of Grenada in 1994 to that in 2001?
Ensure brevity in your answer.  3.79. What is the ratio of the Grants(current US$) in Algeria in 1995 to that in 1996?
Ensure brevity in your answer.  0.81. What is the ratio of the Grants(current US$) in Congo (Republic) in 1995 to that in 1996?
Your response must be concise. 0.29. What is the ratio of the Grants(current US$) in Croatia in 1995 to that in 1996?
Make the answer very short. 1.2. What is the ratio of the Grants(current US$) in Grenada in 1995 to that in 1996?
Make the answer very short. 1.85. What is the ratio of the Grants(current US$) in Algeria in 1995 to that in 1997?
Provide a succinct answer. 2.12. What is the ratio of the Grants(current US$) in Congo (Republic) in 1995 to that in 1997?
Your response must be concise. 0.37. What is the ratio of the Grants(current US$) in Croatia in 1995 to that in 1997?
Provide a succinct answer. 0.79. What is the ratio of the Grants(current US$) of Grenada in 1995 to that in 1997?
Your response must be concise. 1.96. What is the ratio of the Grants(current US$) of Algeria in 1995 to that in 1998?
Your answer should be very brief. 0.67. What is the ratio of the Grants(current US$) in Congo (Republic) in 1995 to that in 1998?
Your response must be concise. 1.62. What is the ratio of the Grants(current US$) of Croatia in 1995 to that in 1998?
Your answer should be compact. 0.86. What is the ratio of the Grants(current US$) of Grenada in 1995 to that in 1998?
Ensure brevity in your answer.  1.97. What is the ratio of the Grants(current US$) in Algeria in 1995 to that in 1999?
Provide a succinct answer. 1.49. What is the ratio of the Grants(current US$) of Congo (Republic) in 1995 to that in 1999?
Your response must be concise. 0.67. What is the ratio of the Grants(current US$) in Croatia in 1995 to that in 1999?
Give a very brief answer. 1.08. What is the ratio of the Grants(current US$) in Grenada in 1995 to that in 1999?
Your answer should be very brief. 4.32. What is the ratio of the Grants(current US$) in Algeria in 1995 to that in 2000?
Offer a terse response. 1.18. What is the ratio of the Grants(current US$) of Congo (Republic) in 1995 to that in 2000?
Offer a very short reply. 2.77. What is the ratio of the Grants(current US$) of Croatia in 1995 to that in 2000?
Provide a succinct answer. 0.67. What is the ratio of the Grants(current US$) of Grenada in 1995 to that in 2000?
Make the answer very short. 1.15. What is the ratio of the Grants(current US$) of Algeria in 1995 to that in 2001?
Your answer should be compact. 1.69. What is the ratio of the Grants(current US$) in Congo (Republic) in 1995 to that in 2001?
Your answer should be very brief. 2.5. What is the ratio of the Grants(current US$) of Croatia in 1995 to that in 2001?
Provide a short and direct response. 0.39. What is the ratio of the Grants(current US$) in Grenada in 1995 to that in 2001?
Keep it short and to the point. 2.54. What is the ratio of the Grants(current US$) in Algeria in 1996 to that in 1997?
Make the answer very short. 2.61. What is the ratio of the Grants(current US$) in Congo (Republic) in 1996 to that in 1997?
Provide a short and direct response. 1.28. What is the ratio of the Grants(current US$) in Croatia in 1996 to that in 1997?
Provide a short and direct response. 0.66. What is the ratio of the Grants(current US$) in Grenada in 1996 to that in 1997?
Provide a succinct answer. 1.06. What is the ratio of the Grants(current US$) in Algeria in 1996 to that in 1998?
Offer a very short reply. 0.82. What is the ratio of the Grants(current US$) in Congo (Republic) in 1996 to that in 1998?
Offer a very short reply. 5.6. What is the ratio of the Grants(current US$) of Croatia in 1996 to that in 1998?
Provide a short and direct response. 0.71. What is the ratio of the Grants(current US$) of Grenada in 1996 to that in 1998?
Your answer should be compact. 1.07. What is the ratio of the Grants(current US$) of Algeria in 1996 to that in 1999?
Give a very brief answer. 1.83. What is the ratio of the Grants(current US$) of Congo (Republic) in 1996 to that in 1999?
Make the answer very short. 2.32. What is the ratio of the Grants(current US$) in Croatia in 1996 to that in 1999?
Offer a very short reply. 0.89. What is the ratio of the Grants(current US$) in Grenada in 1996 to that in 1999?
Make the answer very short. 2.34. What is the ratio of the Grants(current US$) in Algeria in 1996 to that in 2000?
Offer a terse response. 1.45. What is the ratio of the Grants(current US$) in Congo (Republic) in 1996 to that in 2000?
Ensure brevity in your answer.  9.59. What is the ratio of the Grants(current US$) in Croatia in 1996 to that in 2000?
Make the answer very short. 0.55. What is the ratio of the Grants(current US$) of Grenada in 1996 to that in 2000?
Your answer should be very brief. 0.62. What is the ratio of the Grants(current US$) in Algeria in 1996 to that in 2001?
Your response must be concise. 2.08. What is the ratio of the Grants(current US$) of Congo (Republic) in 1996 to that in 2001?
Make the answer very short. 8.65. What is the ratio of the Grants(current US$) in Croatia in 1996 to that in 2001?
Keep it short and to the point. 0.32. What is the ratio of the Grants(current US$) in Grenada in 1996 to that in 2001?
Your answer should be very brief. 1.38. What is the ratio of the Grants(current US$) of Algeria in 1997 to that in 1998?
Your answer should be compact. 0.31. What is the ratio of the Grants(current US$) in Congo (Republic) in 1997 to that in 1998?
Your answer should be very brief. 4.38. What is the ratio of the Grants(current US$) of Croatia in 1997 to that in 1998?
Ensure brevity in your answer.  1.09. What is the ratio of the Grants(current US$) of Algeria in 1997 to that in 1999?
Your response must be concise. 0.7. What is the ratio of the Grants(current US$) in Congo (Republic) in 1997 to that in 1999?
Ensure brevity in your answer.  1.82. What is the ratio of the Grants(current US$) in Croatia in 1997 to that in 1999?
Offer a very short reply. 1.36. What is the ratio of the Grants(current US$) of Grenada in 1997 to that in 1999?
Make the answer very short. 2.2. What is the ratio of the Grants(current US$) in Algeria in 1997 to that in 2000?
Your answer should be compact. 0.56. What is the ratio of the Grants(current US$) of Congo (Republic) in 1997 to that in 2000?
Your answer should be compact. 7.5. What is the ratio of the Grants(current US$) in Croatia in 1997 to that in 2000?
Offer a terse response. 0.84. What is the ratio of the Grants(current US$) in Grenada in 1997 to that in 2000?
Provide a short and direct response. 0.59. What is the ratio of the Grants(current US$) of Algeria in 1997 to that in 2001?
Make the answer very short. 0.8. What is the ratio of the Grants(current US$) of Congo (Republic) in 1997 to that in 2001?
Offer a very short reply. 6.77. What is the ratio of the Grants(current US$) in Croatia in 1997 to that in 2001?
Keep it short and to the point. 0.49. What is the ratio of the Grants(current US$) of Grenada in 1997 to that in 2001?
Provide a short and direct response. 1.29. What is the ratio of the Grants(current US$) in Algeria in 1998 to that in 1999?
Provide a succinct answer. 2.23. What is the ratio of the Grants(current US$) in Congo (Republic) in 1998 to that in 1999?
Keep it short and to the point. 0.41. What is the ratio of the Grants(current US$) in Croatia in 1998 to that in 1999?
Make the answer very short. 1.25. What is the ratio of the Grants(current US$) in Grenada in 1998 to that in 1999?
Give a very brief answer. 2.19. What is the ratio of the Grants(current US$) of Algeria in 1998 to that in 2000?
Your answer should be very brief. 1.76. What is the ratio of the Grants(current US$) in Congo (Republic) in 1998 to that in 2000?
Keep it short and to the point. 1.71. What is the ratio of the Grants(current US$) of Croatia in 1998 to that in 2000?
Ensure brevity in your answer.  0.77. What is the ratio of the Grants(current US$) of Grenada in 1998 to that in 2000?
Your response must be concise. 0.58. What is the ratio of the Grants(current US$) of Algeria in 1998 to that in 2001?
Provide a succinct answer. 2.53. What is the ratio of the Grants(current US$) of Congo (Republic) in 1998 to that in 2001?
Your answer should be very brief. 1.54. What is the ratio of the Grants(current US$) in Croatia in 1998 to that in 2001?
Give a very brief answer. 0.45. What is the ratio of the Grants(current US$) in Grenada in 1998 to that in 2001?
Give a very brief answer. 1.29. What is the ratio of the Grants(current US$) of Algeria in 1999 to that in 2000?
Your response must be concise. 0.79. What is the ratio of the Grants(current US$) in Congo (Republic) in 1999 to that in 2000?
Ensure brevity in your answer.  4.13. What is the ratio of the Grants(current US$) in Croatia in 1999 to that in 2000?
Ensure brevity in your answer.  0.62. What is the ratio of the Grants(current US$) of Grenada in 1999 to that in 2000?
Your answer should be very brief. 0.27. What is the ratio of the Grants(current US$) in Algeria in 1999 to that in 2001?
Give a very brief answer. 1.14. What is the ratio of the Grants(current US$) in Congo (Republic) in 1999 to that in 2001?
Your answer should be compact. 3.72. What is the ratio of the Grants(current US$) of Croatia in 1999 to that in 2001?
Your response must be concise. 0.36. What is the ratio of the Grants(current US$) of Grenada in 1999 to that in 2001?
Your answer should be very brief. 0.59. What is the ratio of the Grants(current US$) of Algeria in 2000 to that in 2001?
Offer a terse response. 1.44. What is the ratio of the Grants(current US$) of Congo (Republic) in 2000 to that in 2001?
Ensure brevity in your answer.  0.9. What is the ratio of the Grants(current US$) in Croatia in 2000 to that in 2001?
Your answer should be very brief. 0.58. What is the ratio of the Grants(current US$) in Grenada in 2000 to that in 2001?
Provide a succinct answer. 2.21. What is the difference between the highest and the second highest Grants(current US$) in Algeria?
Give a very brief answer. 1.92e+07. What is the difference between the highest and the second highest Grants(current US$) in Congo (Republic)?
Ensure brevity in your answer.  6.51e+07. What is the difference between the highest and the second highest Grants(current US$) of Croatia?
Keep it short and to the point. 1.61e+07. What is the difference between the highest and the second highest Grants(current US$) in Grenada?
Ensure brevity in your answer.  4.02e+06. What is the difference between the highest and the lowest Grants(current US$) in Algeria?
Your answer should be compact. 7.36e+07. What is the difference between the highest and the lowest Grants(current US$) of Congo (Republic)?
Provide a succinct answer. 2.68e+08. What is the difference between the highest and the lowest Grants(current US$) in Croatia?
Offer a terse response. 6.95e+07. What is the difference between the highest and the lowest Grants(current US$) in Grenada?
Make the answer very short. 1.03e+07. 